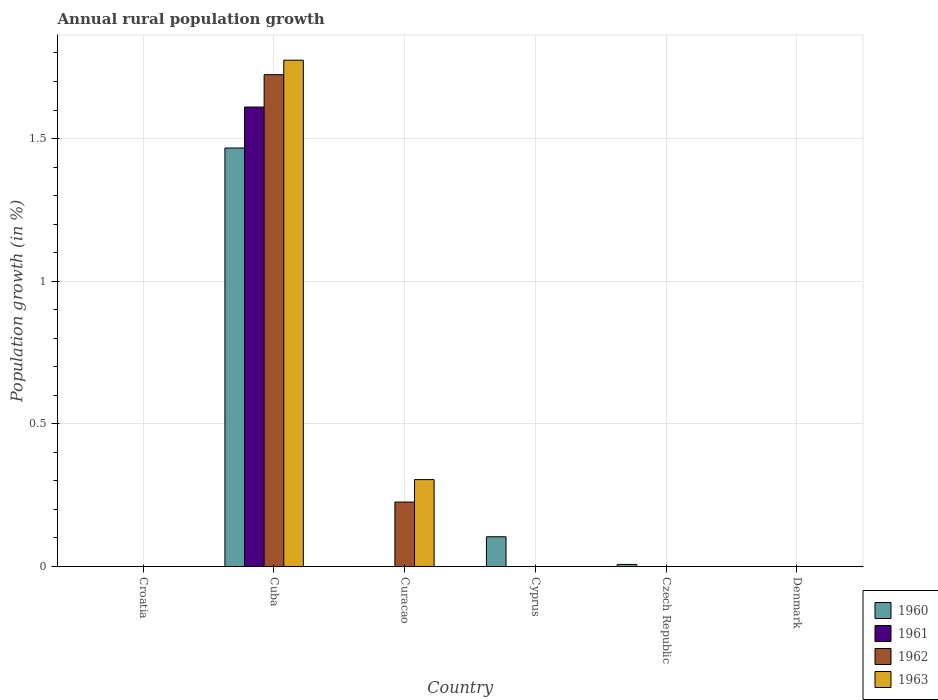How many different coloured bars are there?
Ensure brevity in your answer.  4. Are the number of bars per tick equal to the number of legend labels?
Provide a succinct answer. No. How many bars are there on the 6th tick from the left?
Your response must be concise. 0. What is the label of the 5th group of bars from the left?
Provide a short and direct response. Czech Republic. In how many cases, is the number of bars for a given country not equal to the number of legend labels?
Keep it short and to the point. 5. Across all countries, what is the maximum percentage of rural population growth in 1960?
Ensure brevity in your answer.  1.47. Across all countries, what is the minimum percentage of rural population growth in 1960?
Make the answer very short. 0. In which country was the percentage of rural population growth in 1962 maximum?
Your answer should be compact. Cuba. What is the total percentage of rural population growth in 1960 in the graph?
Your answer should be very brief. 1.58. What is the difference between the percentage of rural population growth in 1963 in Curacao and the percentage of rural population growth in 1960 in Cuba?
Give a very brief answer. -1.16. What is the average percentage of rural population growth in 1961 per country?
Your response must be concise. 0.27. What is the difference between the percentage of rural population growth of/in 1963 and percentage of rural population growth of/in 1960 in Cuba?
Offer a terse response. 0.31. In how many countries, is the percentage of rural population growth in 1963 greater than 0.2 %?
Provide a short and direct response. 2. What is the difference between the highest and the second highest percentage of rural population growth in 1960?
Your response must be concise. -1.36. What is the difference between the highest and the lowest percentage of rural population growth in 1960?
Provide a succinct answer. 1.47. In how many countries, is the percentage of rural population growth in 1961 greater than the average percentage of rural population growth in 1961 taken over all countries?
Ensure brevity in your answer.  1. Is it the case that in every country, the sum of the percentage of rural population growth in 1963 and percentage of rural population growth in 1960 is greater than the sum of percentage of rural population growth in 1962 and percentage of rural population growth in 1961?
Offer a very short reply. No. Is it the case that in every country, the sum of the percentage of rural population growth in 1960 and percentage of rural population growth in 1961 is greater than the percentage of rural population growth in 1962?
Offer a very short reply. No. How many bars are there?
Your answer should be very brief. 8. How many countries are there in the graph?
Your response must be concise. 6. Where does the legend appear in the graph?
Provide a short and direct response. Bottom right. How many legend labels are there?
Give a very brief answer. 4. What is the title of the graph?
Offer a very short reply. Annual rural population growth. What is the label or title of the Y-axis?
Provide a succinct answer. Population growth (in %). What is the Population growth (in %) in 1960 in Croatia?
Offer a very short reply. 0. What is the Population growth (in %) in 1960 in Cuba?
Your response must be concise. 1.47. What is the Population growth (in %) of 1961 in Cuba?
Keep it short and to the point. 1.61. What is the Population growth (in %) of 1962 in Cuba?
Ensure brevity in your answer.  1.72. What is the Population growth (in %) of 1963 in Cuba?
Keep it short and to the point. 1.77. What is the Population growth (in %) of 1962 in Curacao?
Provide a succinct answer. 0.23. What is the Population growth (in %) of 1963 in Curacao?
Make the answer very short. 0.3. What is the Population growth (in %) in 1960 in Cyprus?
Make the answer very short. 0.1. What is the Population growth (in %) in 1961 in Cyprus?
Offer a terse response. 0. What is the Population growth (in %) of 1960 in Czech Republic?
Keep it short and to the point. 0.01. What is the Population growth (in %) of 1963 in Czech Republic?
Ensure brevity in your answer.  0. Across all countries, what is the maximum Population growth (in %) of 1960?
Provide a succinct answer. 1.47. Across all countries, what is the maximum Population growth (in %) of 1961?
Keep it short and to the point. 1.61. Across all countries, what is the maximum Population growth (in %) of 1962?
Ensure brevity in your answer.  1.72. Across all countries, what is the maximum Population growth (in %) of 1963?
Make the answer very short. 1.77. Across all countries, what is the minimum Population growth (in %) of 1960?
Keep it short and to the point. 0. What is the total Population growth (in %) in 1960 in the graph?
Your response must be concise. 1.58. What is the total Population growth (in %) of 1961 in the graph?
Make the answer very short. 1.61. What is the total Population growth (in %) of 1962 in the graph?
Provide a short and direct response. 1.95. What is the total Population growth (in %) in 1963 in the graph?
Offer a terse response. 2.08. What is the difference between the Population growth (in %) of 1962 in Cuba and that in Curacao?
Offer a very short reply. 1.5. What is the difference between the Population growth (in %) in 1963 in Cuba and that in Curacao?
Provide a succinct answer. 1.47. What is the difference between the Population growth (in %) in 1960 in Cuba and that in Cyprus?
Ensure brevity in your answer.  1.36. What is the difference between the Population growth (in %) of 1960 in Cuba and that in Czech Republic?
Make the answer very short. 1.46. What is the difference between the Population growth (in %) in 1960 in Cyprus and that in Czech Republic?
Keep it short and to the point. 0.1. What is the difference between the Population growth (in %) of 1960 in Cuba and the Population growth (in %) of 1962 in Curacao?
Offer a very short reply. 1.24. What is the difference between the Population growth (in %) in 1960 in Cuba and the Population growth (in %) in 1963 in Curacao?
Ensure brevity in your answer.  1.16. What is the difference between the Population growth (in %) of 1961 in Cuba and the Population growth (in %) of 1962 in Curacao?
Ensure brevity in your answer.  1.38. What is the difference between the Population growth (in %) of 1961 in Cuba and the Population growth (in %) of 1963 in Curacao?
Give a very brief answer. 1.31. What is the difference between the Population growth (in %) of 1962 in Cuba and the Population growth (in %) of 1963 in Curacao?
Give a very brief answer. 1.42. What is the average Population growth (in %) in 1960 per country?
Keep it short and to the point. 0.26. What is the average Population growth (in %) in 1961 per country?
Your answer should be compact. 0.27. What is the average Population growth (in %) in 1962 per country?
Keep it short and to the point. 0.32. What is the average Population growth (in %) in 1963 per country?
Ensure brevity in your answer.  0.35. What is the difference between the Population growth (in %) of 1960 and Population growth (in %) of 1961 in Cuba?
Make the answer very short. -0.14. What is the difference between the Population growth (in %) in 1960 and Population growth (in %) in 1962 in Cuba?
Make the answer very short. -0.26. What is the difference between the Population growth (in %) in 1960 and Population growth (in %) in 1963 in Cuba?
Make the answer very short. -0.31. What is the difference between the Population growth (in %) of 1961 and Population growth (in %) of 1962 in Cuba?
Provide a succinct answer. -0.11. What is the difference between the Population growth (in %) of 1961 and Population growth (in %) of 1963 in Cuba?
Ensure brevity in your answer.  -0.16. What is the difference between the Population growth (in %) in 1962 and Population growth (in %) in 1963 in Cuba?
Make the answer very short. -0.05. What is the difference between the Population growth (in %) in 1962 and Population growth (in %) in 1963 in Curacao?
Keep it short and to the point. -0.08. What is the ratio of the Population growth (in %) of 1962 in Cuba to that in Curacao?
Offer a very short reply. 7.63. What is the ratio of the Population growth (in %) of 1963 in Cuba to that in Curacao?
Provide a succinct answer. 5.83. What is the ratio of the Population growth (in %) in 1960 in Cuba to that in Cyprus?
Your response must be concise. 14.08. What is the ratio of the Population growth (in %) in 1960 in Cuba to that in Czech Republic?
Make the answer very short. 202.03. What is the ratio of the Population growth (in %) of 1960 in Cyprus to that in Czech Republic?
Your answer should be very brief. 14.35. What is the difference between the highest and the second highest Population growth (in %) of 1960?
Offer a terse response. 1.36. What is the difference between the highest and the lowest Population growth (in %) of 1960?
Your response must be concise. 1.47. What is the difference between the highest and the lowest Population growth (in %) of 1961?
Your answer should be very brief. 1.61. What is the difference between the highest and the lowest Population growth (in %) of 1962?
Provide a short and direct response. 1.72. What is the difference between the highest and the lowest Population growth (in %) in 1963?
Provide a short and direct response. 1.77. 